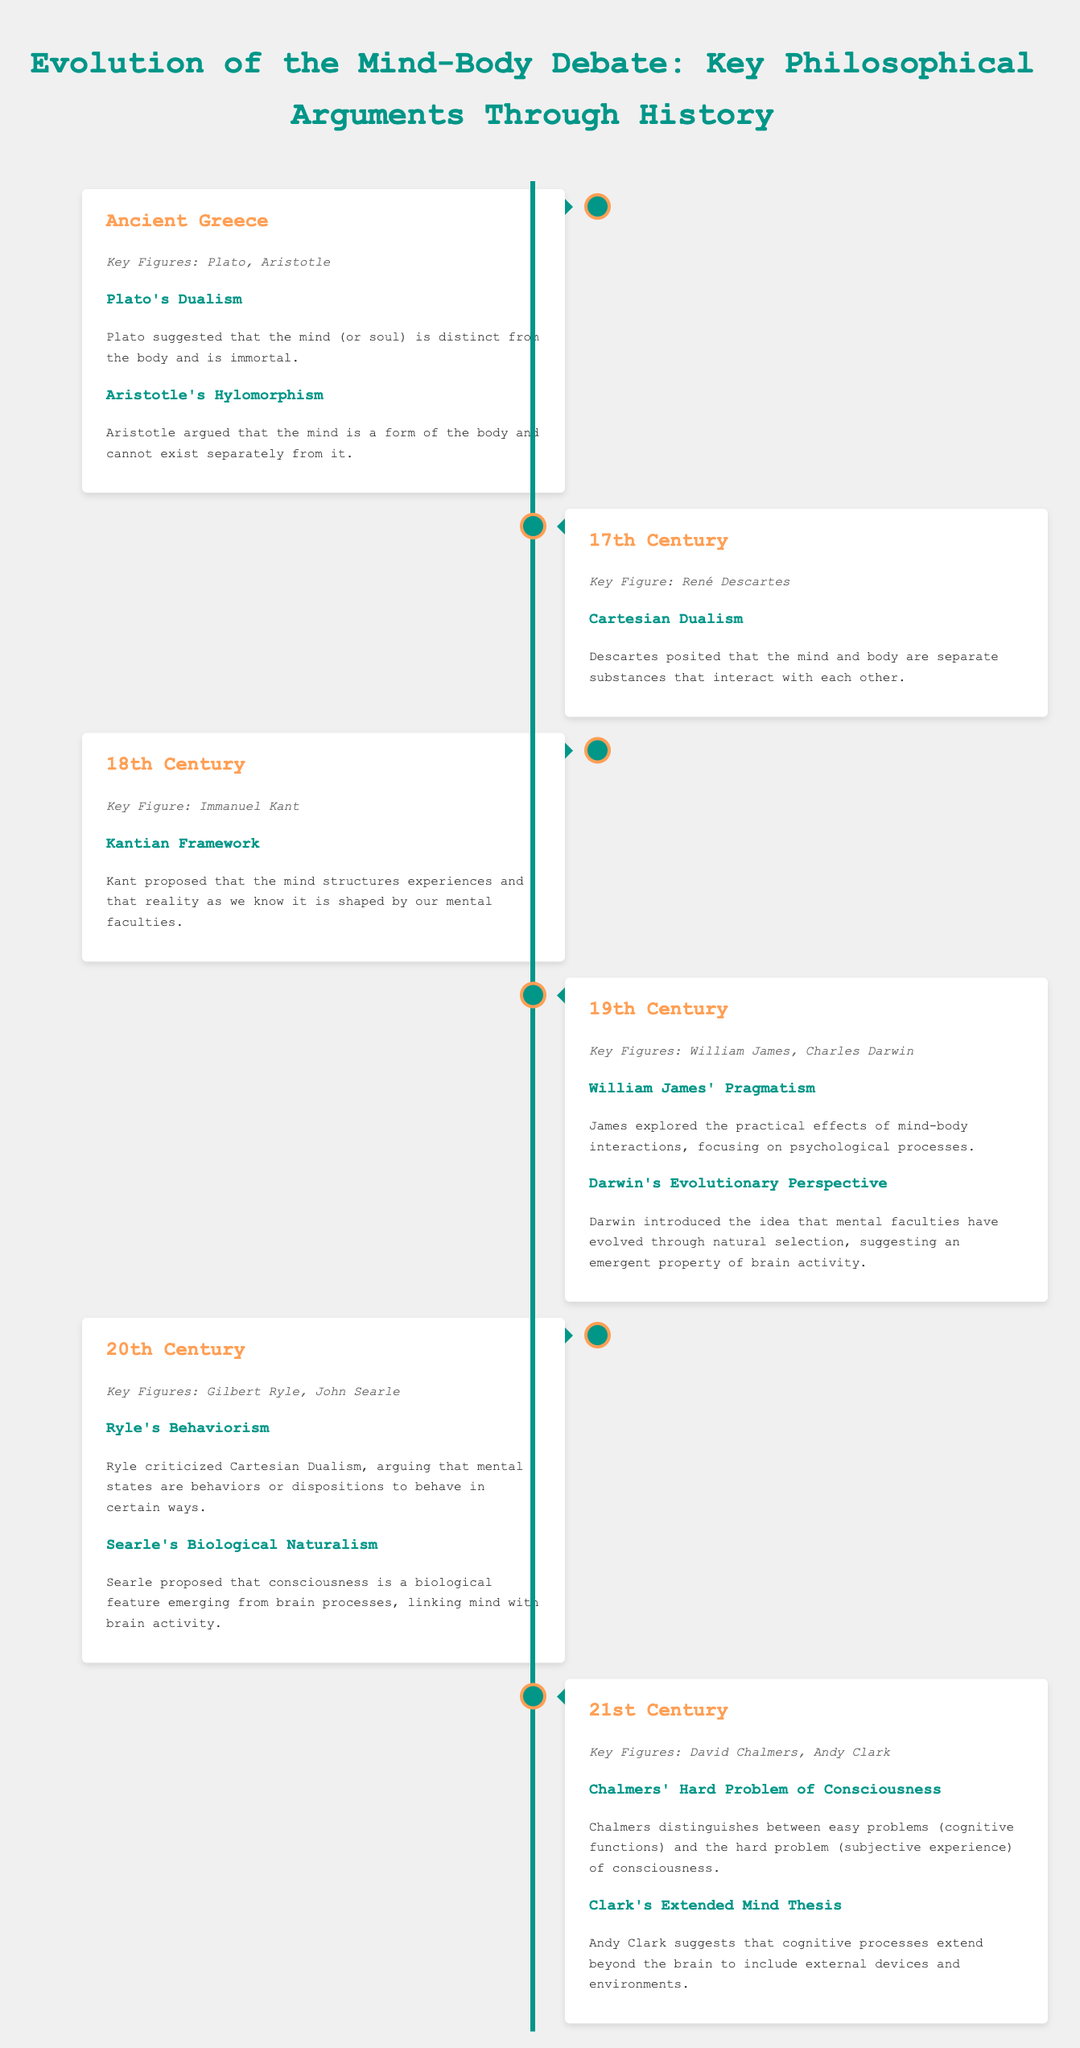What key figure is associated with Cartesian Dualism? The document states that René Descartes is the key figure associated with Cartesian Dualism in the 17th Century.
Answer: René Descartes What distinct belief did Plato propose about the mind? According to the document, Plato suggested that the mind (or soul) is distinct from the body and is immortal.
Answer: Dualism What did Aristotle argue regarding the mind and body? The document explains that Aristotle argued that the mind is a form of the body and cannot exist separately from it.
Answer: Hylomorphism Which century did Immanuel Kant contribute his ideas? The document indicates that Immanuel Kant's contributions occurred in the 18th Century.
Answer: 18th Century What is the "hard problem" of consciousness defined by Chalmers? The document specifies that Chalmers distinguishes between easy problems (cognitive functions) and the hard problem (subjective experience) of consciousness.
Answer: Subjective experience What perspective did Darwin introduce about mental faculties? The document notes that Darwin introduced the idea that mental faculties have evolved through natural selection, suggesting an emergent property of brain activity.
Answer: Evolutionary Perspective What theory is associated with Gilbert Ryle? According to the document, Gilbert Ryle is associated with Behaviorism, which critiques Cartesian Dualism.
Answer: Behaviorism In which century did the Extended Mind Thesis by Andy Clark emerge? The document states that the Extended Mind Thesis by Andy Clark was articulated in the 21st Century.
Answer: 21st Century What is the main focus of William James' pragmatism? The document highlights that William James explored the practical effects of mind-body interactions, focusing on psychological processes.
Answer: Psychological processes 